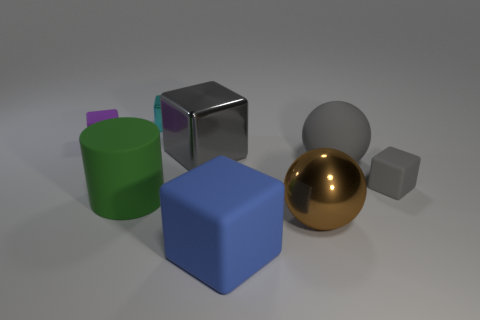Subtract all cyan blocks. How many blocks are left? 4 Subtract all small purple blocks. How many blocks are left? 4 Subtract all red blocks. Subtract all green cylinders. How many blocks are left? 5 Add 1 large blue rubber things. How many objects exist? 9 Subtract all cubes. How many objects are left? 3 Subtract all tiny brown shiny things. Subtract all cubes. How many objects are left? 3 Add 2 brown balls. How many brown balls are left? 3 Add 5 large things. How many large things exist? 10 Subtract 0 red cylinders. How many objects are left? 8 